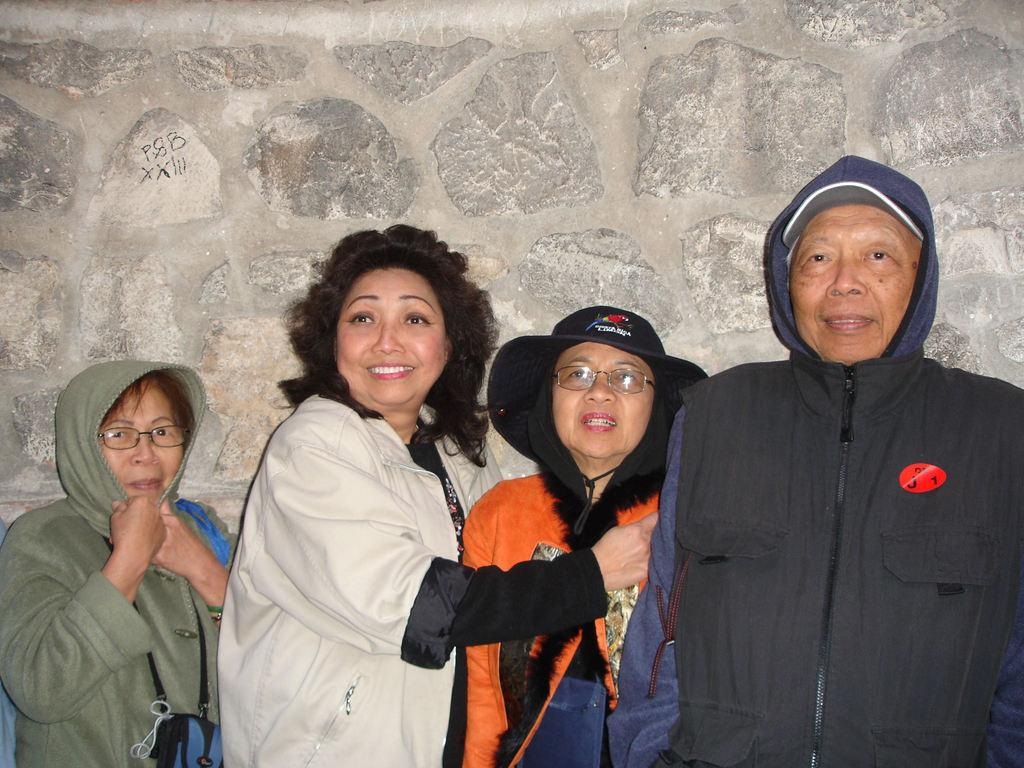How many people are present in the image? There are four people in the image. What are the people doing in the image? The people are standing. What are the people wearing in the image? The people are wearing coats. What can be seen in the background of the image? There is a wall in the image. What type of brush can be seen in the hands of one of the people in the image? There is no brush present in the image; the people are wearing coats and standing near a wall. 